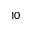Convert formula to latex. <formula><loc_0><loc_0><loc_500><loc_500>1 0</formula> 